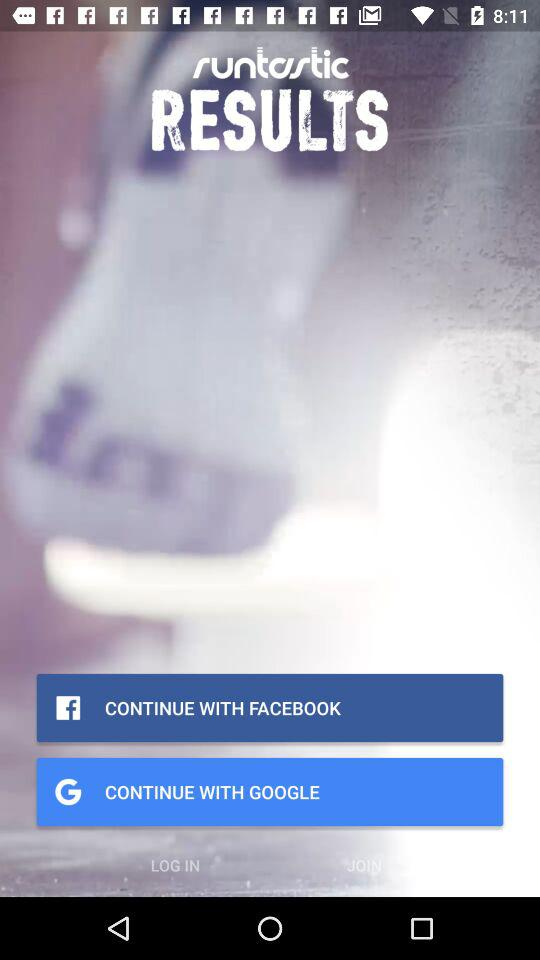What is the application name? The application name is "Runtastic Results". 